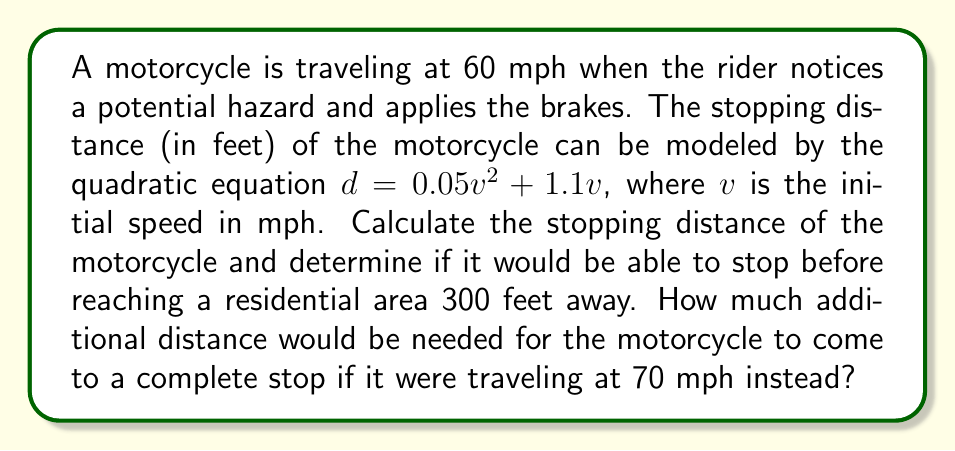Give your solution to this math problem. To solve this problem, we'll follow these steps:

1. Calculate the stopping distance at 60 mph:
   $d = 0.05v^2 + 1.1v$
   $d = 0.05(60)^2 + 1.1(60)$
   $d = 0.05(3600) + 66$
   $d = 180 + 66 = 246$ feet

2. Compare the stopping distance to the distance to the residential area:
   The motorcycle can stop within 246 feet, which is less than the 300 feet to the residential area. Therefore, it can stop in time.

3. Calculate the stopping distance at 70 mph:
   $d = 0.05(70)^2 + 1.1(70)$
   $d = 0.05(4900) + 77$
   $d = 245 + 77 = 322$ feet

4. Calculate the additional distance needed:
   Additional distance = 322 feet - 300 feet = 22 feet

The quadratic equation used in this problem models the relationship between initial speed and stopping distance, taking into account both the reaction time of the rider (represented by the linear term) and the physical limitations of the motorcycle's braking system (represented by the quadratic term).
Answer: The motorcycle traveling at 60 mph would stop within 246 feet, which is before reaching the residential area. If traveling at 70 mph, it would require an additional 22 feet beyond the 300-foot mark to come to a complete stop. 